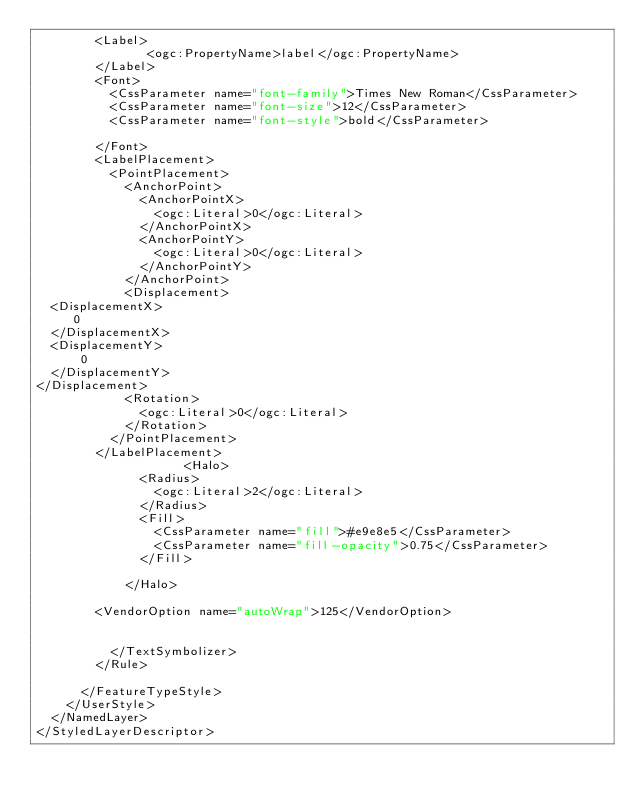<code> <loc_0><loc_0><loc_500><loc_500><_Scheme_>        <Label>
               <ogc:PropertyName>label</ogc:PropertyName>
        </Label>
        <Font>
          <CssParameter name="font-family">Times New Roman</CssParameter>
          <CssParameter name="font-size">12</CssParameter>
          <CssParameter name="font-style">bold</CssParameter>

        </Font>
        <LabelPlacement>
          <PointPlacement>
            <AnchorPoint>
              <AnchorPointX>
                <ogc:Literal>0</ogc:Literal>
              </AnchorPointX>
              <AnchorPointY>
                <ogc:Literal>0</ogc:Literal>
              </AnchorPointY>
            </AnchorPoint>
            <Displacement>
  <DisplacementX>
     0
  </DisplacementX>
  <DisplacementY>
      0
  </DisplacementY>
</Displacement>
            <Rotation>
              <ogc:Literal>0</ogc:Literal>
            </Rotation>
          </PointPlacement>
        </LabelPlacement>
                    <Halo>
              <Radius>
                <ogc:Literal>2</ogc:Literal>
              </Radius>
              <Fill>
                <CssParameter name="fill">#e9e8e5</CssParameter>
                <CssParameter name="fill-opacity">0.75</CssParameter>
              </Fill>

            </Halo>

        <VendorOption name="autoWrap">125</VendorOption>
    

          </TextSymbolizer>
        </Rule>

      </FeatureTypeStyle>
    </UserStyle>
  </NamedLayer>
</StyledLayerDescriptor></code> 